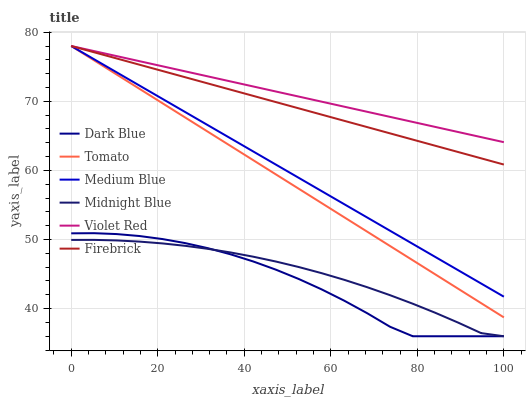Does Midnight Blue have the minimum area under the curve?
Answer yes or no. No. Does Midnight Blue have the maximum area under the curve?
Answer yes or no. No. Is Violet Red the smoothest?
Answer yes or no. No. Is Violet Red the roughest?
Answer yes or no. No. Does Violet Red have the lowest value?
Answer yes or no. No. Does Midnight Blue have the highest value?
Answer yes or no. No. Is Midnight Blue less than Firebrick?
Answer yes or no. Yes. Is Firebrick greater than Midnight Blue?
Answer yes or no. Yes. Does Midnight Blue intersect Firebrick?
Answer yes or no. No. 